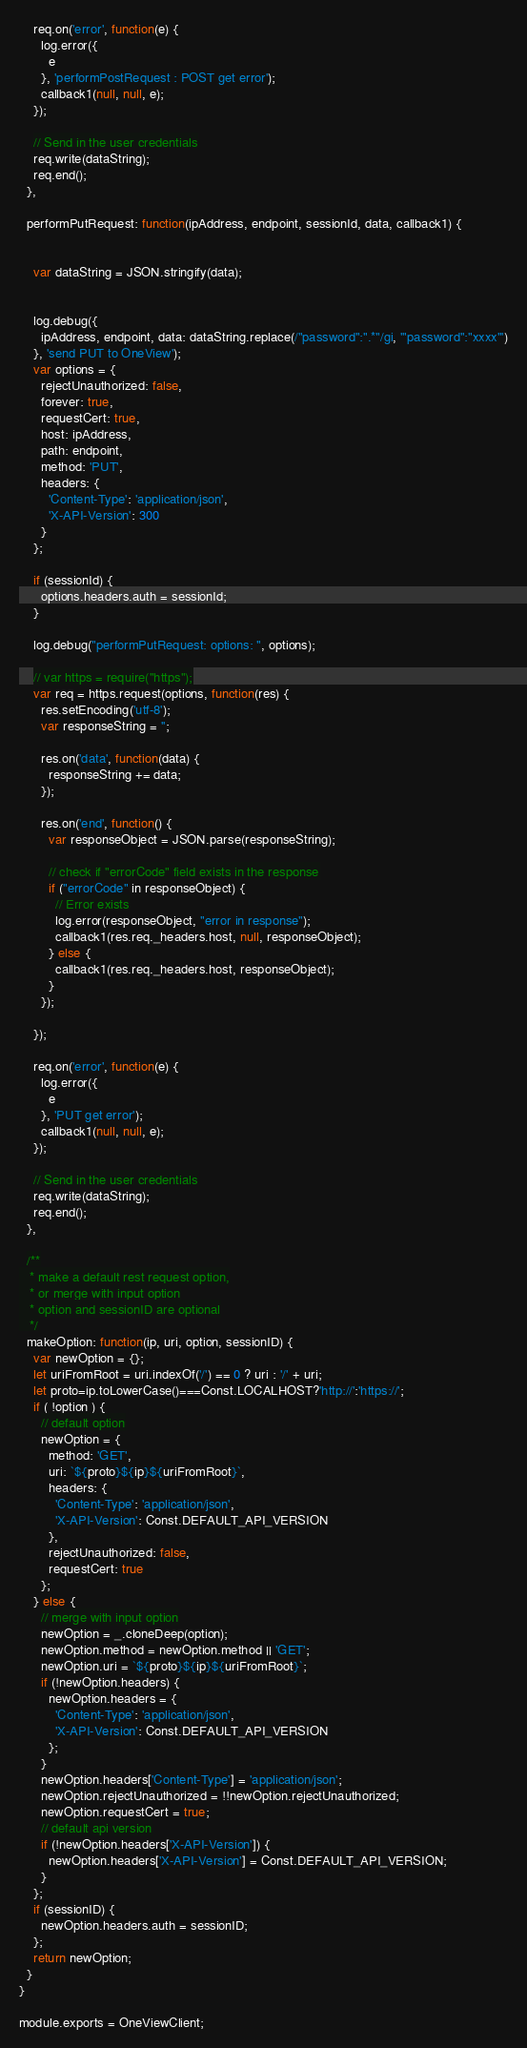Convert code to text. <code><loc_0><loc_0><loc_500><loc_500><_JavaScript_>
    req.on('error', function(e) {
      log.error({
        e
      }, 'performPostRequest : POST get error');
      callback1(null, null, e);
    });

    // Send in the user credentials
    req.write(dataString);
    req.end();
  },

  performPutRequest: function(ipAddress, endpoint, sessionId, data, callback1) {


    var dataString = JSON.stringify(data);


    log.debug({
      ipAddress, endpoint, data: dataString.replace(/"password":".*"/gi, '"password":"xxxx"')
    }, 'send PUT to OneView');
    var options = {
      rejectUnauthorized: false,
      forever: true,
      requestCert: true,
      host: ipAddress,
      path: endpoint,
      method: 'PUT',
      headers: {
        'Content-Type': 'application/json',
        'X-API-Version': 300
      }
    };

    if (sessionId) {
      options.headers.auth = sessionId;
    }

    log.debug("performPutRequest: options: ", options);

    // var https = require("https");
    var req = https.request(options, function(res) {
      res.setEncoding('utf-8');
      var responseString = '';

      res.on('data', function(data) {
        responseString += data;
      });

      res.on('end', function() {
        var responseObject = JSON.parse(responseString);

        // check if "errorCode" field exists in the response
        if ("errorCode" in responseObject) {
          // Error exists
          log.error(responseObject, "error in response");
          callback1(res.req._headers.host, null, responseObject);
        } else {
          callback1(res.req._headers.host, responseObject);
        }
      });

    });

    req.on('error', function(e) {
      log.error({
        e
      }, 'PUT get error');
      callback1(null, null, e);
    });

    // Send in the user credentials
    req.write(dataString);
    req.end();
  },

  /**
   * make a default rest request option,
   * or merge with input option
   * option and sessionID are optional
   */
  makeOption: function(ip, uri, option, sessionID) {
    var newOption = {};
    let uriFromRoot = uri.indexOf('/') == 0 ? uri : '/' + uri;
    let proto=ip.toLowerCase()===Const.LOCALHOST?'http://':'https://';
    if ( !option ) {
      // default option
      newOption = {
        method: 'GET',
        uri: `${proto}${ip}${uriFromRoot}`,
        headers: {
          'Content-Type': 'application/json',
          'X-API-Version': Const.DEFAULT_API_VERSION
        },
        rejectUnauthorized: false,
        requestCert: true
      };
    } else {
      // merge with input option
      newOption = _.cloneDeep(option);
      newOption.method = newOption.method || 'GET';
      newOption.uri = `${proto}${ip}${uriFromRoot}`;
      if (!newOption.headers) {
        newOption.headers = {
          'Content-Type': 'application/json',
          'X-API-Version': Const.DEFAULT_API_VERSION
        };
      }
      newOption.headers['Content-Type'] = 'application/json';
      newOption.rejectUnauthorized = !!newOption.rejectUnauthorized;
      newOption.requestCert = true;
      // default api version
      if (!newOption.headers['X-API-Version']) {
        newOption.headers['X-API-Version'] = Const.DEFAULT_API_VERSION;
      }
    };
    if (sessionID) {
      newOption.headers.auth = sessionID;
    };
    return newOption;
  }
}

module.exports = OneViewClient;
</code> 